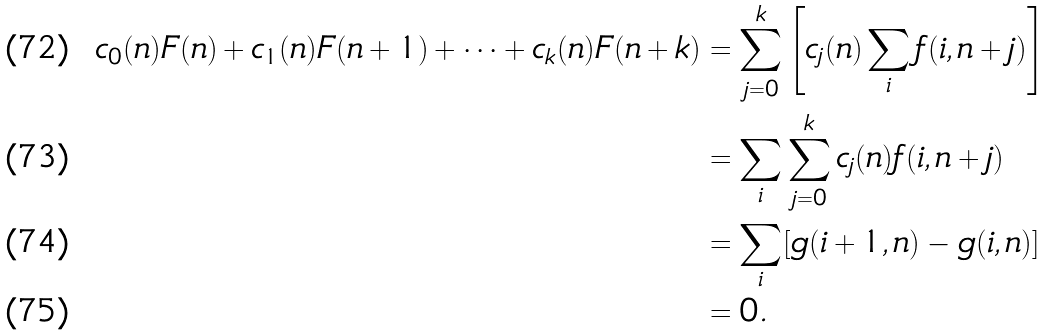Convert formula to latex. <formula><loc_0><loc_0><loc_500><loc_500>c _ { 0 } ( n ) F ( n ) + c _ { 1 } ( n ) F ( n + 1 ) + \cdots + c _ { k } ( n ) F ( n + k ) & = \sum _ { j = 0 } ^ { k } \left [ c _ { j } ( n ) \sum _ { i } f ( i , n + j ) \right ] \\ & = \sum _ { i } \sum _ { j = 0 } ^ { k } c _ { j } ( n ) f ( i , n + j ) \\ & = \sum _ { i } [ g ( i + 1 , n ) - g ( i , n ) ] \\ & = 0 .</formula> 